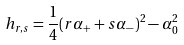<formula> <loc_0><loc_0><loc_500><loc_500>h _ { r , s } = \frac { 1 } { 4 } ( r \alpha _ { + } + s \alpha _ { - } ) ^ { 2 } - \alpha _ { 0 } ^ { 2 }</formula> 